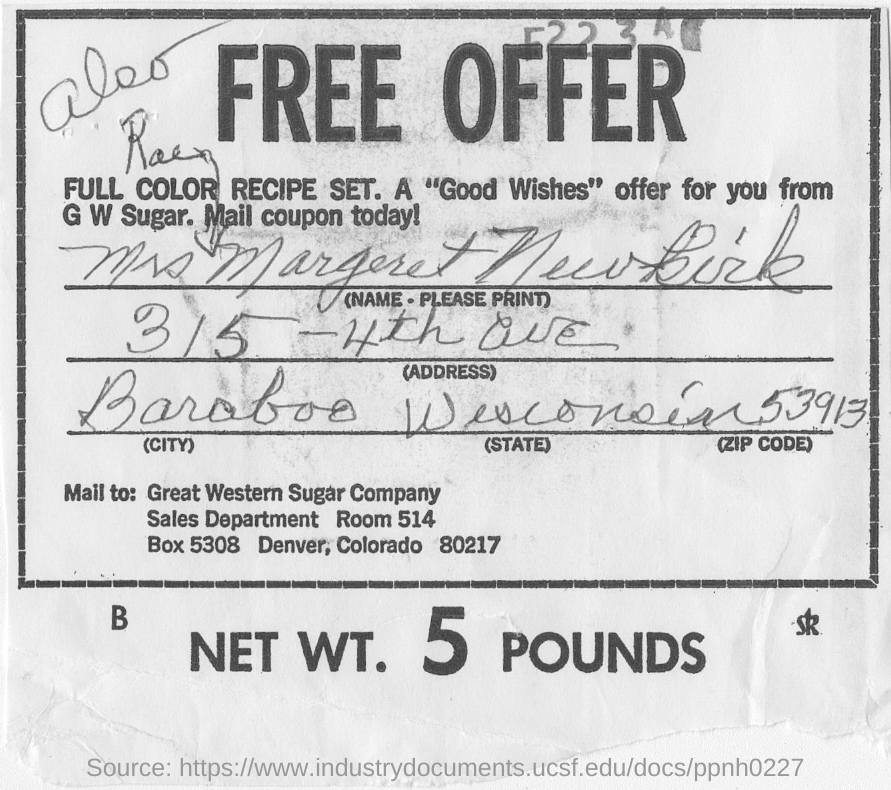What is the zip code of Colorado? Colorado has multiple zip codes depending on the location within the state. For instance, Denver, the capital of Colorado, has several zip codes, ranging from 80201 to 80299. If you are seeking a specific location's zip code within Colorado, it's best to use a zip code lookup tool with an exact address or area in mind. 